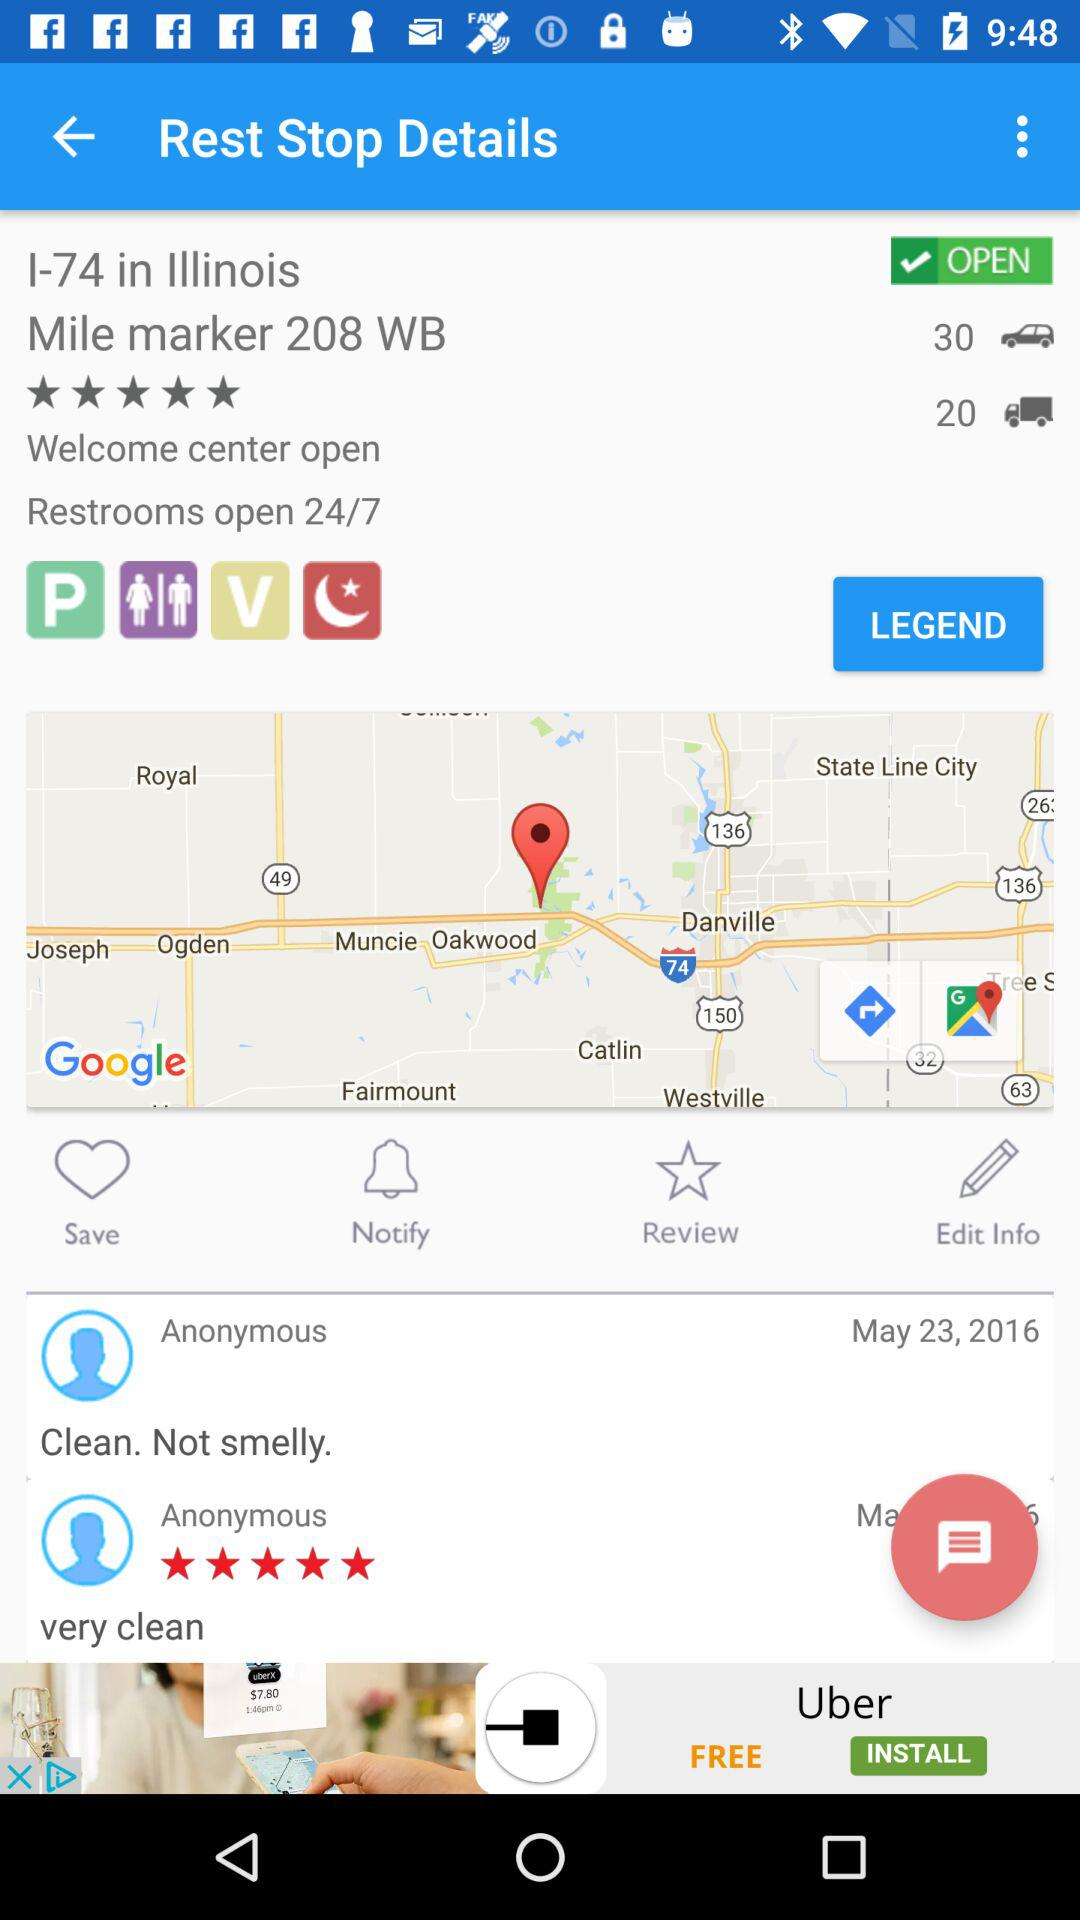When do the restrooms open? The restrooms are open 24/7. 